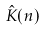Convert formula to latex. <formula><loc_0><loc_0><loc_500><loc_500>\hat { K } ( n )</formula> 